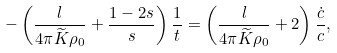<formula> <loc_0><loc_0><loc_500><loc_500>- \left ( \frac { l } { 4 \pi \widetilde { K } \rho _ { 0 } } + \frac { 1 - 2 s } { s } \right ) \frac { 1 } { t } = \left ( \frac { l } { 4 \pi \widetilde { K } \rho _ { 0 } } + 2 \right ) \frac { \dot { c } } { c } ,</formula> 